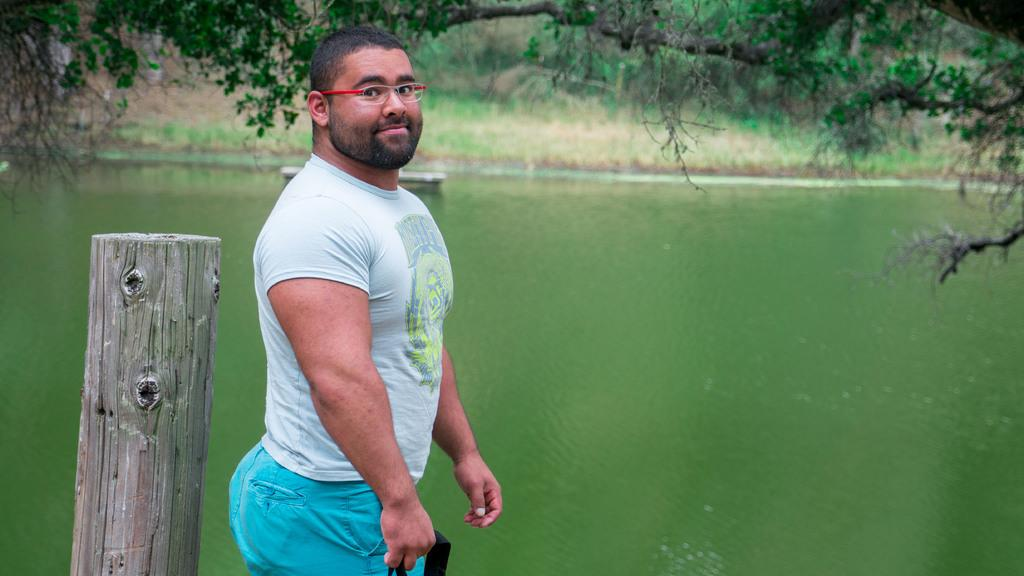What can be seen in the image? There is a person in the image. What is the person wearing? The person is wearing a t-shirt and blue pants. What is the person doing in the image? The person is standing. What is behind the person? There is a wooden log behind the person. What can be seen in the background of the image? Water, grass, and trees are visible in the background. What type of basket is being used to reduce friction in the image? There is no basket or mention of friction in the image. 